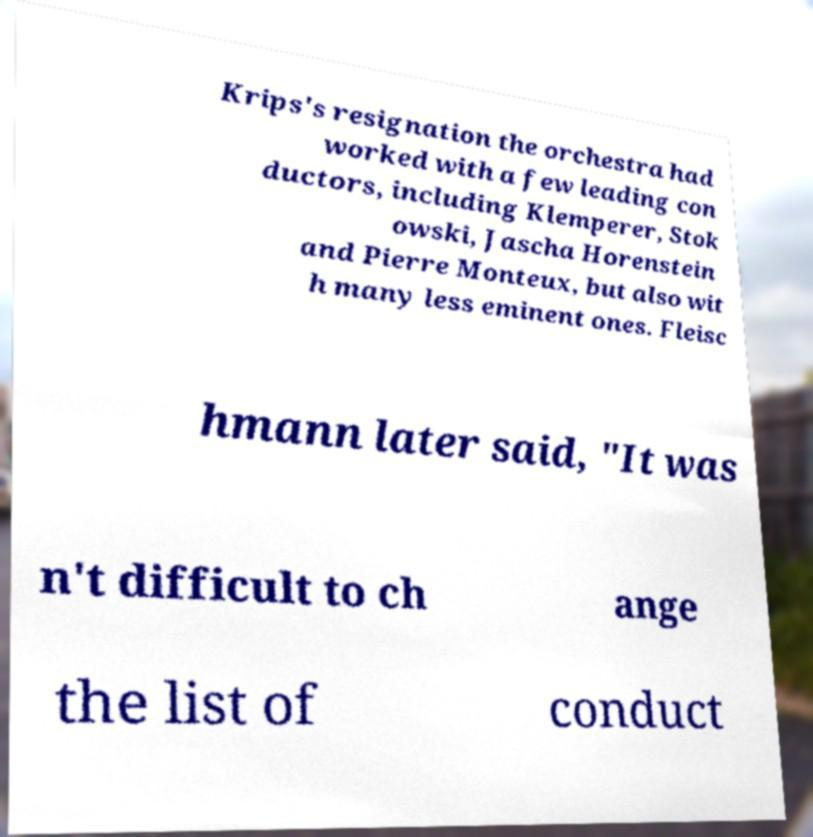Can you accurately transcribe the text from the provided image for me? Krips's resignation the orchestra had worked with a few leading con ductors, including Klemperer, Stok owski, Jascha Horenstein and Pierre Monteux, but also wit h many less eminent ones. Fleisc hmann later said, "It was n't difficult to ch ange the list of conduct 